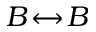<formula> <loc_0><loc_0><loc_500><loc_500>B \, \leftrightarrow \, B</formula> 